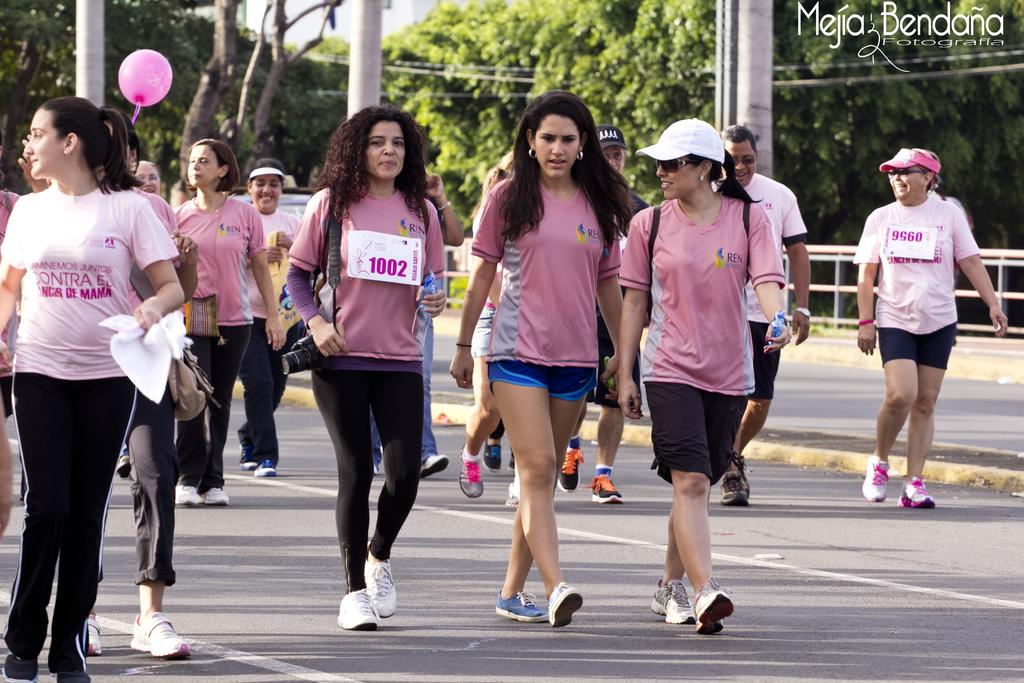How many people are in the image? There is a group of persons in the image. What are the people in the image doing? The group of persons is walking. What can be seen in the background of the image? There are trees and poles in the background of the image. What color is the balloon in the image? There is a pink balloon in the image. What type of plant is being used as a quiver by the persons in the image? There is no plant or quiver present in the image. How many horses are accompanying the group of persons in the image? There are no horses present in the image. 